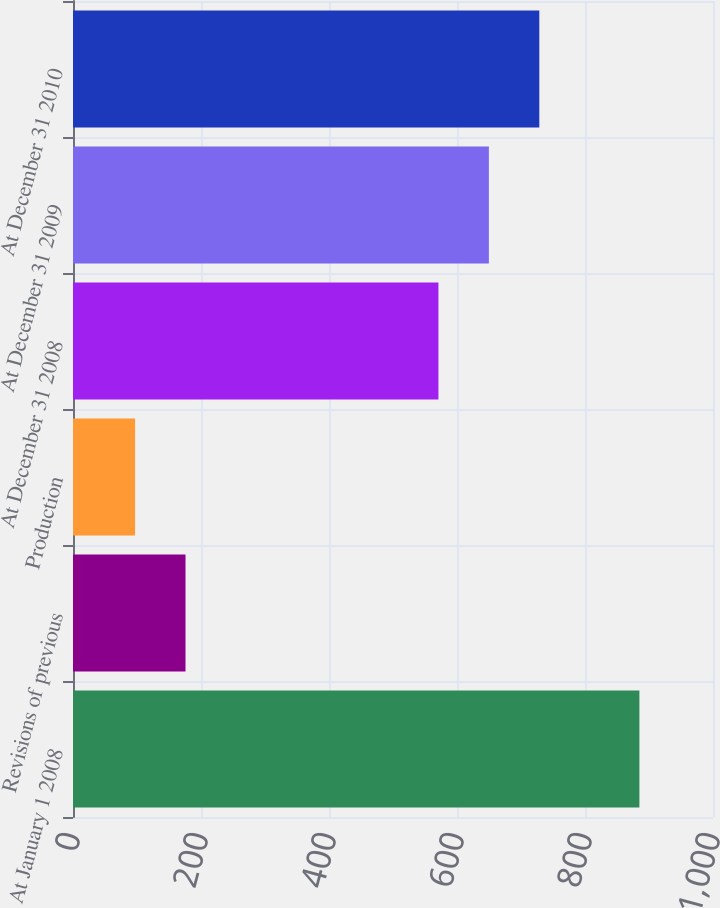<chart> <loc_0><loc_0><loc_500><loc_500><bar_chart><fcel>At January 1 2008<fcel>Revisions of previous<fcel>Production<fcel>At December 31 2008<fcel>At December 31 2009<fcel>At December 31 2010<nl><fcel>885<fcel>175.8<fcel>97<fcel>571<fcel>649.8<fcel>728.6<nl></chart> 